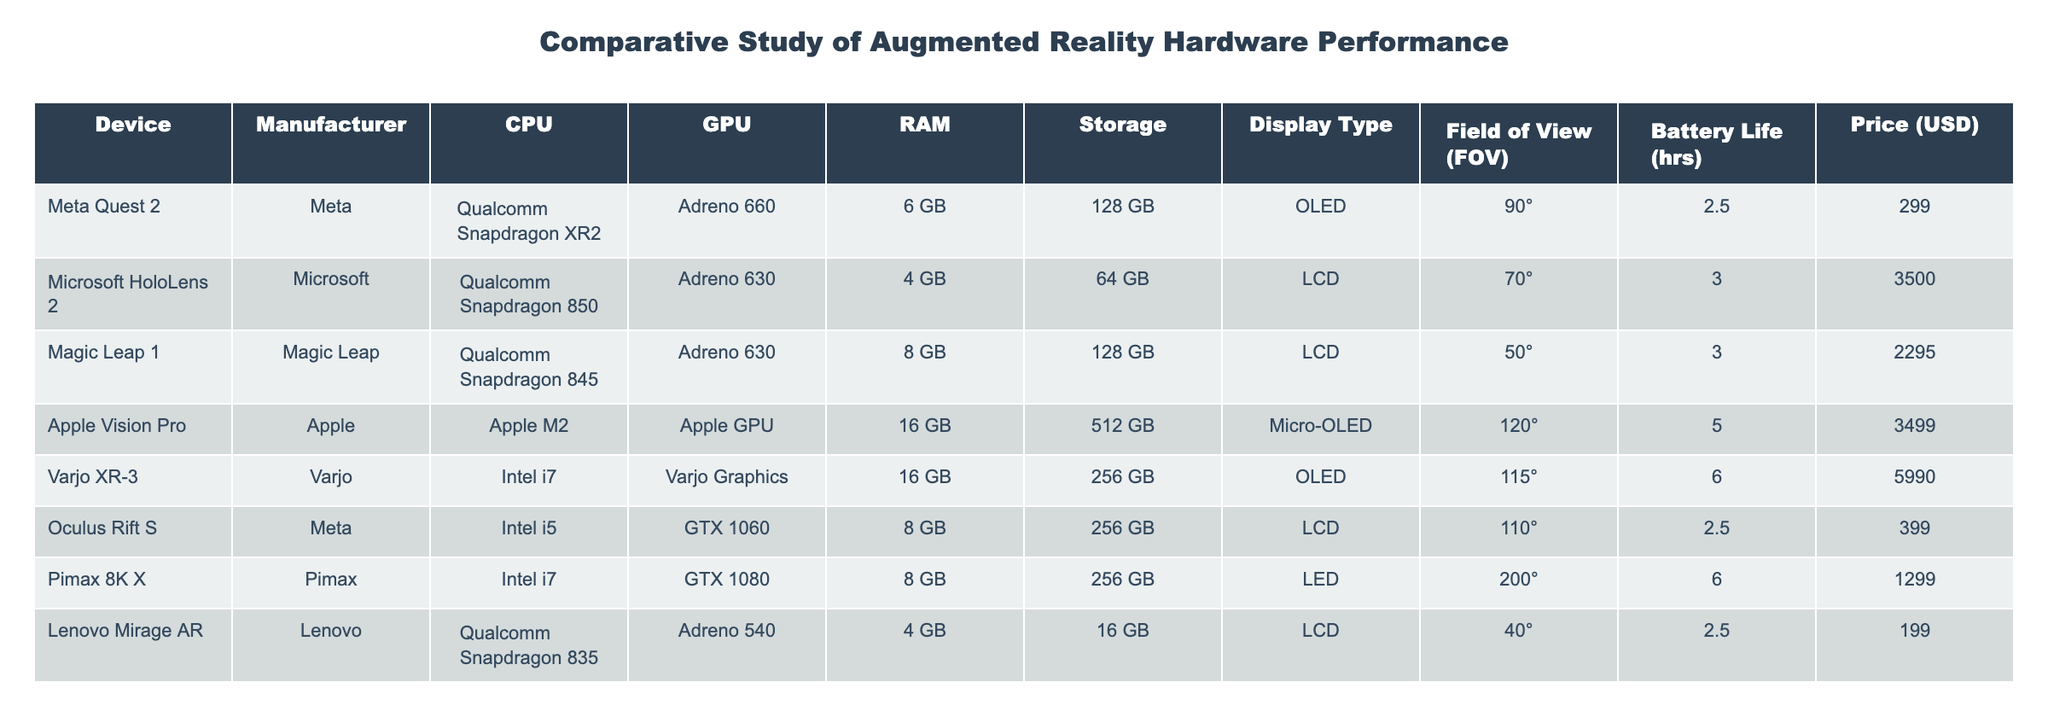What is the price of the Meta Quest 2? The price is explicitly listed in the table under the Price column next to the Meta Quest 2 row, which shows 299 USD.
Answer: 299 USD Which device has the longest battery life? By examining the Battery Life column, we identify the maximum value. Comparing values across each device: Meta Quest 2 (2.5), Microsoft HoloLens 2 (3), Magic Leap 1 (3), Apple Vision Pro (5), Varjo XR-3 (6), Oculus Rift S (2.5), Pimax 8K X (6), Lenovo Mirage AR (2.5), we find the Varjo XR-3 and Pimax 8K X both have the longest battery life of 6 hours.
Answer: Varjo XR-3 and Pimax 8K X What is the average RAM of the devices listed? First, we sum all the RAM values: 6 + 4 + 8 + 16 + 16 + 8 + 8 + 4 = 70. There are 8 devices. To get the average, we divide the total RAM by the number of devices: 70 / 8 = 8.75.
Answer: 8.75 GB Is the Magic Leap 1 more expensive than the Oculus Rift S? Comparing the prices in the table, Magic Leap 1 costs 2295 USD while Oculus Rift S costs 399 USD. Since 2295 > 399, this statement is true.
Answer: Yes What is the total storage of devices that have OLED displays? The devices with OLED displays are Meta Quest 2 (128 GB), Varjo XR-3 (256 GB), and Pimax 8K X (256 GB). Summing these values: 128 + 256 + 256 = 640 GB.
Answer: 640 GB Which device has the highest field of view and what is that value? Looking at the Field of View (FOV) column, the values are compared among the devices. Pimax 8K X shows a FOV of 200°, which is higher than all other devices, confirming it has the highest field of view.
Answer: 200° Is the Apple Vision Pro a more affordable option than the Varjo XR-3? The price of Apple Vision Pro is 3499 USD, while the Varjo XR-3 is priced at 5990 USD. Since 3499 < 5990, it is indeed more affordable.
Answer: Yes What is the difference in battery life between the HoloLens 2 and the Apple Vision Pro? Battery life for HoloLens 2 is 3 hours, and for Apple Vision Pro, it is 5 hours. To find the difference: 5 - 3 = 2 hours, indicating Apple Vision Pro has 2 hours more battery life.
Answer: 2 hours 